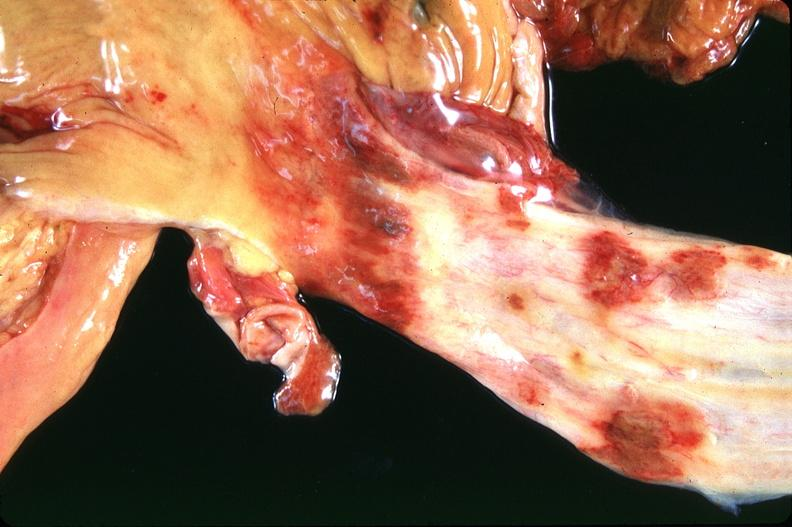what does this image show?
Answer the question using a single word or phrase. Stomach and esophagus 